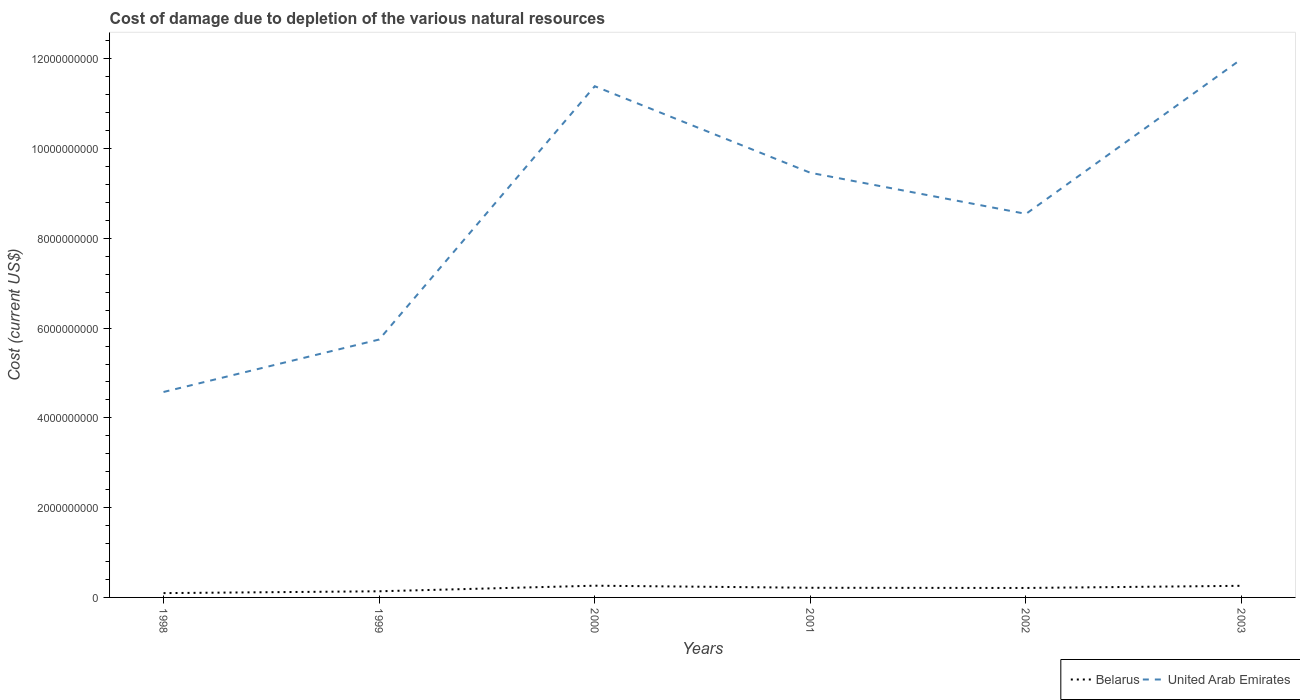Across all years, what is the maximum cost of damage caused due to the depletion of various natural resources in United Arab Emirates?
Provide a short and direct response. 4.58e+09. In which year was the cost of damage caused due to the depletion of various natural resources in Belarus maximum?
Give a very brief answer. 1998. What is the total cost of damage caused due to the depletion of various natural resources in Belarus in the graph?
Offer a very short reply. -1.15e+08. What is the difference between the highest and the second highest cost of damage caused due to the depletion of various natural resources in Belarus?
Provide a succinct answer. 1.65e+08. What is the difference between the highest and the lowest cost of damage caused due to the depletion of various natural resources in Belarus?
Give a very brief answer. 4. Is the cost of damage caused due to the depletion of various natural resources in Belarus strictly greater than the cost of damage caused due to the depletion of various natural resources in United Arab Emirates over the years?
Make the answer very short. Yes. What is the difference between two consecutive major ticks on the Y-axis?
Provide a succinct answer. 2.00e+09. Where does the legend appear in the graph?
Provide a short and direct response. Bottom right. How are the legend labels stacked?
Provide a succinct answer. Horizontal. What is the title of the graph?
Make the answer very short. Cost of damage due to depletion of the various natural resources. Does "Lao PDR" appear as one of the legend labels in the graph?
Ensure brevity in your answer.  No. What is the label or title of the Y-axis?
Provide a short and direct response. Cost (current US$). What is the Cost (current US$) of Belarus in 1998?
Your response must be concise. 9.61e+07. What is the Cost (current US$) of United Arab Emirates in 1998?
Keep it short and to the point. 4.58e+09. What is the Cost (current US$) of Belarus in 1999?
Provide a short and direct response. 1.37e+08. What is the Cost (current US$) in United Arab Emirates in 1999?
Ensure brevity in your answer.  5.75e+09. What is the Cost (current US$) in Belarus in 2000?
Your response must be concise. 2.61e+08. What is the Cost (current US$) in United Arab Emirates in 2000?
Your answer should be very brief. 1.14e+1. What is the Cost (current US$) in Belarus in 2001?
Provide a short and direct response. 2.15e+08. What is the Cost (current US$) in United Arab Emirates in 2001?
Your response must be concise. 9.46e+09. What is the Cost (current US$) of Belarus in 2002?
Your response must be concise. 2.11e+08. What is the Cost (current US$) of United Arab Emirates in 2002?
Provide a short and direct response. 8.54e+09. What is the Cost (current US$) of Belarus in 2003?
Offer a very short reply. 2.59e+08. What is the Cost (current US$) in United Arab Emirates in 2003?
Your answer should be very brief. 1.20e+1. Across all years, what is the maximum Cost (current US$) of Belarus?
Keep it short and to the point. 2.61e+08. Across all years, what is the maximum Cost (current US$) of United Arab Emirates?
Make the answer very short. 1.20e+1. Across all years, what is the minimum Cost (current US$) of Belarus?
Keep it short and to the point. 9.61e+07. Across all years, what is the minimum Cost (current US$) in United Arab Emirates?
Give a very brief answer. 4.58e+09. What is the total Cost (current US$) in Belarus in the graph?
Offer a terse response. 1.18e+09. What is the total Cost (current US$) of United Arab Emirates in the graph?
Your response must be concise. 5.17e+1. What is the difference between the Cost (current US$) in Belarus in 1998 and that in 1999?
Provide a succinct answer. -4.09e+07. What is the difference between the Cost (current US$) of United Arab Emirates in 1998 and that in 1999?
Give a very brief answer. -1.17e+09. What is the difference between the Cost (current US$) in Belarus in 1998 and that in 2000?
Keep it short and to the point. -1.65e+08. What is the difference between the Cost (current US$) of United Arab Emirates in 1998 and that in 2000?
Your response must be concise. -6.81e+09. What is the difference between the Cost (current US$) in Belarus in 1998 and that in 2001?
Provide a succinct answer. -1.19e+08. What is the difference between the Cost (current US$) in United Arab Emirates in 1998 and that in 2001?
Your response must be concise. -4.88e+09. What is the difference between the Cost (current US$) of Belarus in 1998 and that in 2002?
Offer a terse response. -1.15e+08. What is the difference between the Cost (current US$) in United Arab Emirates in 1998 and that in 2002?
Your answer should be very brief. -3.97e+09. What is the difference between the Cost (current US$) in Belarus in 1998 and that in 2003?
Offer a very short reply. -1.63e+08. What is the difference between the Cost (current US$) in United Arab Emirates in 1998 and that in 2003?
Provide a short and direct response. -7.42e+09. What is the difference between the Cost (current US$) in Belarus in 1999 and that in 2000?
Offer a very short reply. -1.24e+08. What is the difference between the Cost (current US$) in United Arab Emirates in 1999 and that in 2000?
Ensure brevity in your answer.  -5.64e+09. What is the difference between the Cost (current US$) of Belarus in 1999 and that in 2001?
Your response must be concise. -7.81e+07. What is the difference between the Cost (current US$) of United Arab Emirates in 1999 and that in 2001?
Your answer should be compact. -3.71e+09. What is the difference between the Cost (current US$) in Belarus in 1999 and that in 2002?
Keep it short and to the point. -7.39e+07. What is the difference between the Cost (current US$) of United Arab Emirates in 1999 and that in 2002?
Your answer should be compact. -2.80e+09. What is the difference between the Cost (current US$) of Belarus in 1999 and that in 2003?
Offer a terse response. -1.22e+08. What is the difference between the Cost (current US$) of United Arab Emirates in 1999 and that in 2003?
Your response must be concise. -6.25e+09. What is the difference between the Cost (current US$) in Belarus in 2000 and that in 2001?
Give a very brief answer. 4.62e+07. What is the difference between the Cost (current US$) of United Arab Emirates in 2000 and that in 2001?
Provide a succinct answer. 1.93e+09. What is the difference between the Cost (current US$) in Belarus in 2000 and that in 2002?
Provide a short and direct response. 5.05e+07. What is the difference between the Cost (current US$) in United Arab Emirates in 2000 and that in 2002?
Offer a terse response. 2.84e+09. What is the difference between the Cost (current US$) in Belarus in 2000 and that in 2003?
Your answer should be very brief. 2.52e+06. What is the difference between the Cost (current US$) of United Arab Emirates in 2000 and that in 2003?
Keep it short and to the point. -6.07e+08. What is the difference between the Cost (current US$) of Belarus in 2001 and that in 2002?
Make the answer very short. 4.25e+06. What is the difference between the Cost (current US$) of United Arab Emirates in 2001 and that in 2002?
Keep it short and to the point. 9.15e+08. What is the difference between the Cost (current US$) in Belarus in 2001 and that in 2003?
Make the answer very short. -4.37e+07. What is the difference between the Cost (current US$) of United Arab Emirates in 2001 and that in 2003?
Keep it short and to the point. -2.54e+09. What is the difference between the Cost (current US$) of Belarus in 2002 and that in 2003?
Offer a terse response. -4.80e+07. What is the difference between the Cost (current US$) of United Arab Emirates in 2002 and that in 2003?
Offer a terse response. -3.45e+09. What is the difference between the Cost (current US$) of Belarus in 1998 and the Cost (current US$) of United Arab Emirates in 1999?
Provide a short and direct response. -5.65e+09. What is the difference between the Cost (current US$) in Belarus in 1998 and the Cost (current US$) in United Arab Emirates in 2000?
Ensure brevity in your answer.  -1.13e+1. What is the difference between the Cost (current US$) in Belarus in 1998 and the Cost (current US$) in United Arab Emirates in 2001?
Ensure brevity in your answer.  -9.36e+09. What is the difference between the Cost (current US$) in Belarus in 1998 and the Cost (current US$) in United Arab Emirates in 2002?
Your answer should be very brief. -8.45e+09. What is the difference between the Cost (current US$) of Belarus in 1998 and the Cost (current US$) of United Arab Emirates in 2003?
Offer a very short reply. -1.19e+1. What is the difference between the Cost (current US$) in Belarus in 1999 and the Cost (current US$) in United Arab Emirates in 2000?
Make the answer very short. -1.13e+1. What is the difference between the Cost (current US$) in Belarus in 1999 and the Cost (current US$) in United Arab Emirates in 2001?
Keep it short and to the point. -9.32e+09. What is the difference between the Cost (current US$) of Belarus in 1999 and the Cost (current US$) of United Arab Emirates in 2002?
Provide a succinct answer. -8.41e+09. What is the difference between the Cost (current US$) of Belarus in 1999 and the Cost (current US$) of United Arab Emirates in 2003?
Make the answer very short. -1.19e+1. What is the difference between the Cost (current US$) of Belarus in 2000 and the Cost (current US$) of United Arab Emirates in 2001?
Make the answer very short. -9.20e+09. What is the difference between the Cost (current US$) of Belarus in 2000 and the Cost (current US$) of United Arab Emirates in 2002?
Offer a terse response. -8.28e+09. What is the difference between the Cost (current US$) of Belarus in 2000 and the Cost (current US$) of United Arab Emirates in 2003?
Offer a very short reply. -1.17e+1. What is the difference between the Cost (current US$) in Belarus in 2001 and the Cost (current US$) in United Arab Emirates in 2002?
Ensure brevity in your answer.  -8.33e+09. What is the difference between the Cost (current US$) of Belarus in 2001 and the Cost (current US$) of United Arab Emirates in 2003?
Your answer should be compact. -1.18e+1. What is the difference between the Cost (current US$) of Belarus in 2002 and the Cost (current US$) of United Arab Emirates in 2003?
Make the answer very short. -1.18e+1. What is the average Cost (current US$) in Belarus per year?
Make the answer very short. 1.97e+08. What is the average Cost (current US$) in United Arab Emirates per year?
Provide a short and direct response. 8.62e+09. In the year 1998, what is the difference between the Cost (current US$) in Belarus and Cost (current US$) in United Arab Emirates?
Provide a short and direct response. -4.48e+09. In the year 1999, what is the difference between the Cost (current US$) in Belarus and Cost (current US$) in United Arab Emirates?
Give a very brief answer. -5.61e+09. In the year 2000, what is the difference between the Cost (current US$) in Belarus and Cost (current US$) in United Arab Emirates?
Your answer should be very brief. -1.11e+1. In the year 2001, what is the difference between the Cost (current US$) of Belarus and Cost (current US$) of United Arab Emirates?
Your answer should be compact. -9.25e+09. In the year 2002, what is the difference between the Cost (current US$) in Belarus and Cost (current US$) in United Arab Emirates?
Offer a very short reply. -8.33e+09. In the year 2003, what is the difference between the Cost (current US$) of Belarus and Cost (current US$) of United Arab Emirates?
Give a very brief answer. -1.17e+1. What is the ratio of the Cost (current US$) of Belarus in 1998 to that in 1999?
Make the answer very short. 0.7. What is the ratio of the Cost (current US$) of United Arab Emirates in 1998 to that in 1999?
Provide a short and direct response. 0.8. What is the ratio of the Cost (current US$) of Belarus in 1998 to that in 2000?
Offer a very short reply. 0.37. What is the ratio of the Cost (current US$) in United Arab Emirates in 1998 to that in 2000?
Ensure brevity in your answer.  0.4. What is the ratio of the Cost (current US$) in Belarus in 1998 to that in 2001?
Keep it short and to the point. 0.45. What is the ratio of the Cost (current US$) of United Arab Emirates in 1998 to that in 2001?
Offer a terse response. 0.48. What is the ratio of the Cost (current US$) in Belarus in 1998 to that in 2002?
Provide a short and direct response. 0.46. What is the ratio of the Cost (current US$) in United Arab Emirates in 1998 to that in 2002?
Provide a short and direct response. 0.54. What is the ratio of the Cost (current US$) in Belarus in 1998 to that in 2003?
Offer a terse response. 0.37. What is the ratio of the Cost (current US$) in United Arab Emirates in 1998 to that in 2003?
Your answer should be compact. 0.38. What is the ratio of the Cost (current US$) in Belarus in 1999 to that in 2000?
Your answer should be very brief. 0.52. What is the ratio of the Cost (current US$) of United Arab Emirates in 1999 to that in 2000?
Ensure brevity in your answer.  0.5. What is the ratio of the Cost (current US$) of Belarus in 1999 to that in 2001?
Your response must be concise. 0.64. What is the ratio of the Cost (current US$) in United Arab Emirates in 1999 to that in 2001?
Provide a short and direct response. 0.61. What is the ratio of the Cost (current US$) of Belarus in 1999 to that in 2002?
Ensure brevity in your answer.  0.65. What is the ratio of the Cost (current US$) in United Arab Emirates in 1999 to that in 2002?
Provide a succinct answer. 0.67. What is the ratio of the Cost (current US$) of Belarus in 1999 to that in 2003?
Give a very brief answer. 0.53. What is the ratio of the Cost (current US$) in United Arab Emirates in 1999 to that in 2003?
Provide a succinct answer. 0.48. What is the ratio of the Cost (current US$) in Belarus in 2000 to that in 2001?
Your answer should be very brief. 1.21. What is the ratio of the Cost (current US$) in United Arab Emirates in 2000 to that in 2001?
Your response must be concise. 1.2. What is the ratio of the Cost (current US$) of Belarus in 2000 to that in 2002?
Your answer should be very brief. 1.24. What is the ratio of the Cost (current US$) in United Arab Emirates in 2000 to that in 2002?
Provide a succinct answer. 1.33. What is the ratio of the Cost (current US$) of Belarus in 2000 to that in 2003?
Offer a terse response. 1.01. What is the ratio of the Cost (current US$) of United Arab Emirates in 2000 to that in 2003?
Offer a terse response. 0.95. What is the ratio of the Cost (current US$) of Belarus in 2001 to that in 2002?
Keep it short and to the point. 1.02. What is the ratio of the Cost (current US$) in United Arab Emirates in 2001 to that in 2002?
Offer a very short reply. 1.11. What is the ratio of the Cost (current US$) of Belarus in 2001 to that in 2003?
Your response must be concise. 0.83. What is the ratio of the Cost (current US$) of United Arab Emirates in 2001 to that in 2003?
Your answer should be compact. 0.79. What is the ratio of the Cost (current US$) of Belarus in 2002 to that in 2003?
Give a very brief answer. 0.81. What is the ratio of the Cost (current US$) in United Arab Emirates in 2002 to that in 2003?
Provide a succinct answer. 0.71. What is the difference between the highest and the second highest Cost (current US$) of Belarus?
Your answer should be very brief. 2.52e+06. What is the difference between the highest and the second highest Cost (current US$) of United Arab Emirates?
Keep it short and to the point. 6.07e+08. What is the difference between the highest and the lowest Cost (current US$) of Belarus?
Give a very brief answer. 1.65e+08. What is the difference between the highest and the lowest Cost (current US$) in United Arab Emirates?
Provide a short and direct response. 7.42e+09. 